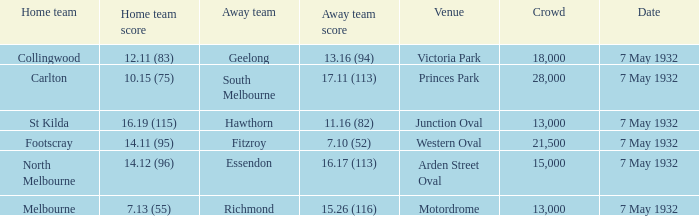What is the total of crowd with Home team score of 14.12 (96)? 15000.0. 